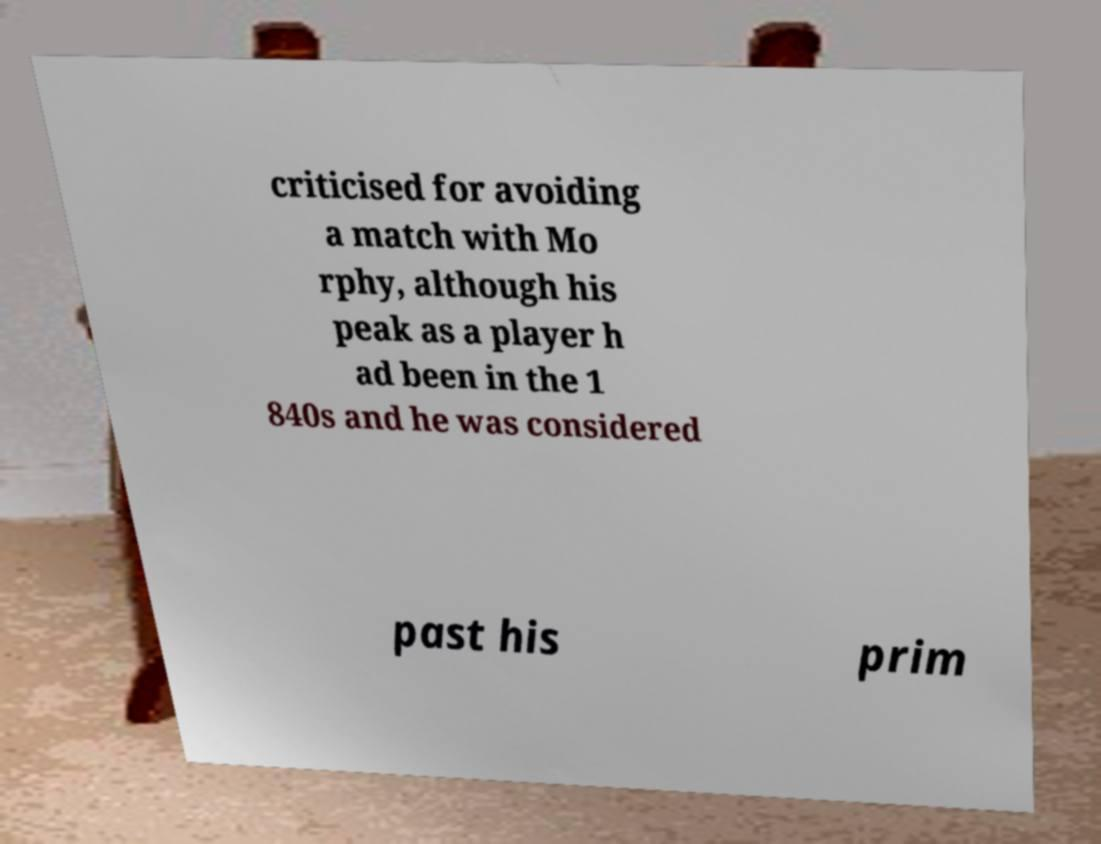There's text embedded in this image that I need extracted. Can you transcribe it verbatim? criticised for avoiding a match with Mo rphy, although his peak as a player h ad been in the 1 840s and he was considered past his prim 